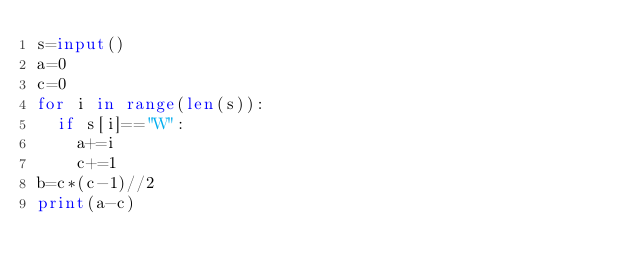<code> <loc_0><loc_0><loc_500><loc_500><_Python_>s=input()
a=0
c=0
for i in range(len(s)):
  if s[i]=="W":
    a+=i
    c+=1
b=c*(c-1)//2
print(a-c)</code> 